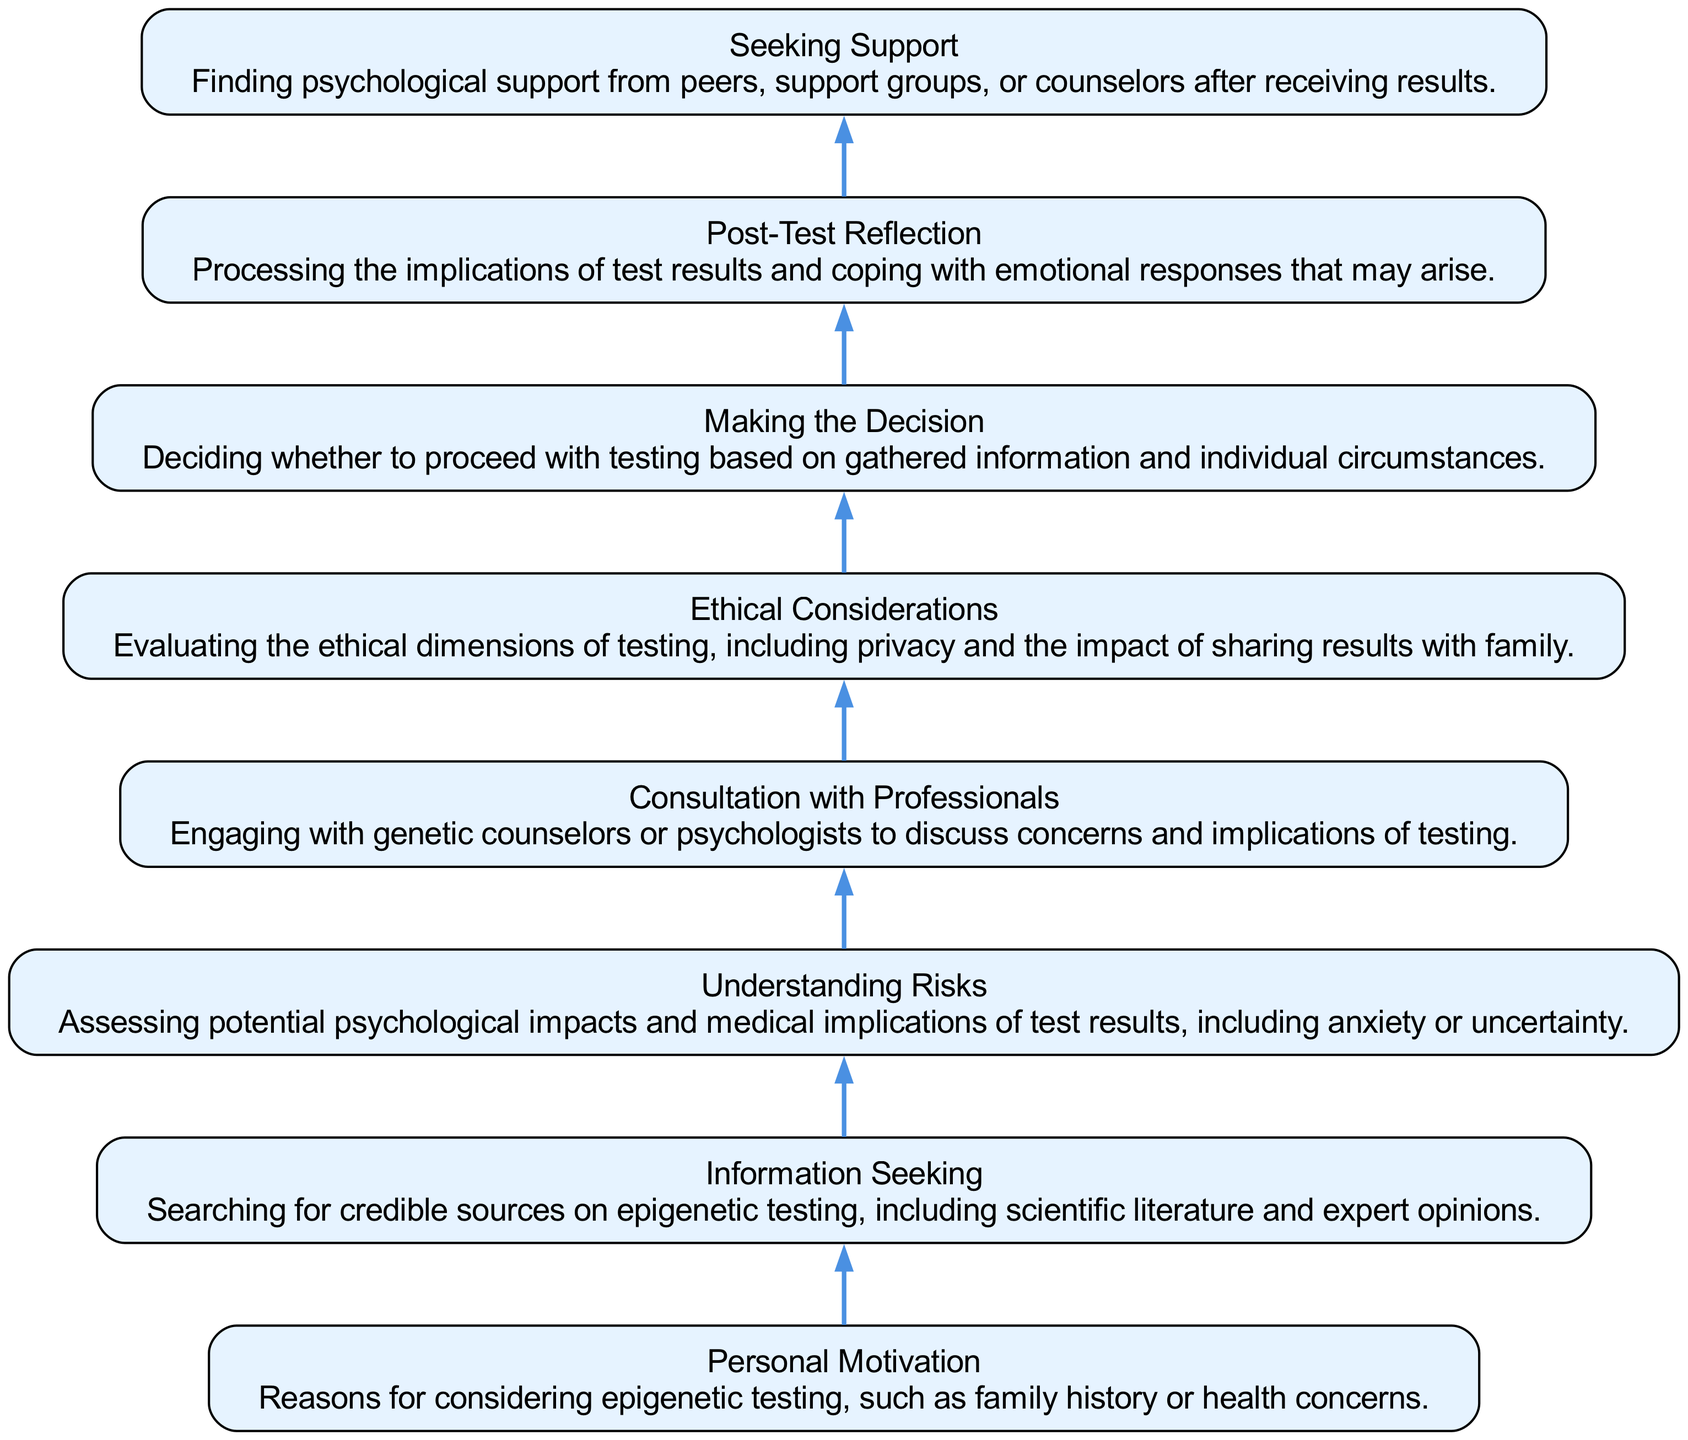What is the first element in the diagram? The first element in the diagram is the one that appears at the bottom of the flow chart, representing the initial stage of decision-making. In this case, it is "Personal Motivation."
Answer: Personal Motivation How many elements are in the diagram? Counting each unique step or node listed in the diagram indicates the total number of elements. There are eight distinct elements in the flow chart.
Answer: 8 What follows "Information Seeking" in the flow chart? Reviewing the diagram, the node that directly follows "Information Seeking" indicates the next stage in the decision-making process. That element is "Understanding Risks."
Answer: Understanding Risks What is the last element in the diagram? The last element represents the final outcome or stage in the decision process, which is "Seeking Support." It is the endpoint of the flow chart.
Answer: Seeking Support Which element assesses potential psychological impacts? Looking through the diagram, "Understanding Risks" is the element that specifies the evaluation of potential psychological impacts associated with the test results.
Answer: Understanding Risks What element involves discussing concerns with professionals? In the flow of the diagram, the step where individuals engage with experts is labeled as "Consultation with Professionals." This step specifically focuses on that aspect.
Answer: Consultation with Professionals What is the primary focus of "Ethical Considerations"? Examining the description provided in the flow chart shows that "Ethical Considerations" primarily involves evaluating the ethical dimensions, including privacy implications.
Answer: Evaluating the ethical dimensions Identify the two elements directly connected to "Making the Decision." By analyzing the structure of the diagram, "Understanding Risks" leads into "Making the Decision" and subsequently leads to "Post-Test Reflection," indicating a direct link to both preceding and following elements.
Answer: Understanding Risks and Post-Test Reflection 